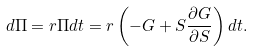Convert formula to latex. <formula><loc_0><loc_0><loc_500><loc_500>d \Pi = r \Pi d t = r \left ( - G + S \frac { \partial G } { \partial S } \right ) d t .</formula> 